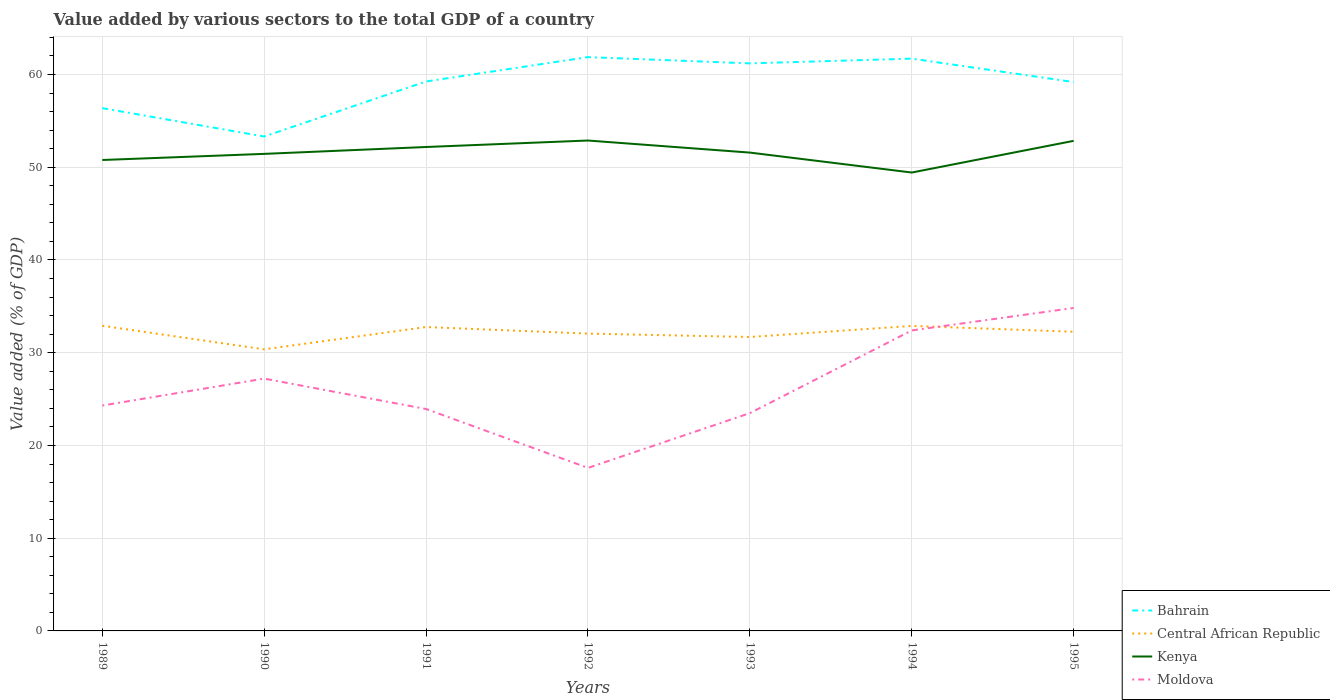Is the number of lines equal to the number of legend labels?
Ensure brevity in your answer.  Yes. Across all years, what is the maximum value added by various sectors to the total GDP in Kenya?
Provide a succinct answer. 49.43. In which year was the value added by various sectors to the total GDP in Moldova maximum?
Give a very brief answer. 1992. What is the total value added by various sectors to the total GDP in Bahrain in the graph?
Keep it short and to the point. -0.51. What is the difference between the highest and the second highest value added by various sectors to the total GDP in Central African Republic?
Make the answer very short. 2.54. How many lines are there?
Your answer should be compact. 4. What is the difference between two consecutive major ticks on the Y-axis?
Give a very brief answer. 10. Does the graph contain any zero values?
Offer a very short reply. No. Does the graph contain grids?
Your response must be concise. Yes. How many legend labels are there?
Make the answer very short. 4. How are the legend labels stacked?
Give a very brief answer. Vertical. What is the title of the graph?
Offer a terse response. Value added by various sectors to the total GDP of a country. Does "Korea (Republic)" appear as one of the legend labels in the graph?
Your answer should be compact. No. What is the label or title of the Y-axis?
Your answer should be compact. Value added (% of GDP). What is the Value added (% of GDP) of Bahrain in 1989?
Make the answer very short. 56.38. What is the Value added (% of GDP) of Central African Republic in 1989?
Provide a short and direct response. 32.91. What is the Value added (% of GDP) in Kenya in 1989?
Your answer should be compact. 50.78. What is the Value added (% of GDP) of Moldova in 1989?
Ensure brevity in your answer.  24.31. What is the Value added (% of GDP) of Bahrain in 1990?
Your answer should be compact. 53.32. What is the Value added (% of GDP) in Central African Republic in 1990?
Keep it short and to the point. 30.37. What is the Value added (% of GDP) of Kenya in 1990?
Ensure brevity in your answer.  51.44. What is the Value added (% of GDP) in Moldova in 1990?
Your answer should be compact. 27.21. What is the Value added (% of GDP) in Bahrain in 1991?
Your answer should be very brief. 59.25. What is the Value added (% of GDP) of Central African Republic in 1991?
Offer a very short reply. 32.77. What is the Value added (% of GDP) in Kenya in 1991?
Your answer should be compact. 52.18. What is the Value added (% of GDP) of Moldova in 1991?
Offer a very short reply. 23.93. What is the Value added (% of GDP) in Bahrain in 1992?
Your response must be concise. 61.88. What is the Value added (% of GDP) of Central African Republic in 1992?
Your answer should be compact. 32.06. What is the Value added (% of GDP) in Kenya in 1992?
Your answer should be very brief. 52.88. What is the Value added (% of GDP) of Moldova in 1992?
Your answer should be compact. 17.58. What is the Value added (% of GDP) in Bahrain in 1993?
Make the answer very short. 61.2. What is the Value added (% of GDP) of Central African Republic in 1993?
Your answer should be compact. 31.7. What is the Value added (% of GDP) of Kenya in 1993?
Your response must be concise. 51.58. What is the Value added (% of GDP) of Moldova in 1993?
Provide a short and direct response. 23.49. What is the Value added (% of GDP) in Bahrain in 1994?
Provide a succinct answer. 61.71. What is the Value added (% of GDP) of Central African Republic in 1994?
Provide a succinct answer. 32.89. What is the Value added (% of GDP) of Kenya in 1994?
Your answer should be compact. 49.43. What is the Value added (% of GDP) of Moldova in 1994?
Provide a succinct answer. 32.41. What is the Value added (% of GDP) of Bahrain in 1995?
Provide a succinct answer. 59.19. What is the Value added (% of GDP) of Central African Republic in 1995?
Keep it short and to the point. 32.26. What is the Value added (% of GDP) in Kenya in 1995?
Your response must be concise. 52.85. What is the Value added (% of GDP) in Moldova in 1995?
Ensure brevity in your answer.  34.83. Across all years, what is the maximum Value added (% of GDP) of Bahrain?
Keep it short and to the point. 61.88. Across all years, what is the maximum Value added (% of GDP) of Central African Republic?
Offer a terse response. 32.91. Across all years, what is the maximum Value added (% of GDP) of Kenya?
Offer a very short reply. 52.88. Across all years, what is the maximum Value added (% of GDP) in Moldova?
Offer a very short reply. 34.83. Across all years, what is the minimum Value added (% of GDP) in Bahrain?
Make the answer very short. 53.32. Across all years, what is the minimum Value added (% of GDP) in Central African Republic?
Make the answer very short. 30.37. Across all years, what is the minimum Value added (% of GDP) in Kenya?
Your answer should be very brief. 49.43. Across all years, what is the minimum Value added (% of GDP) of Moldova?
Offer a very short reply. 17.58. What is the total Value added (% of GDP) in Bahrain in the graph?
Your answer should be compact. 412.93. What is the total Value added (% of GDP) of Central African Republic in the graph?
Make the answer very short. 224.96. What is the total Value added (% of GDP) of Kenya in the graph?
Give a very brief answer. 361.16. What is the total Value added (% of GDP) of Moldova in the graph?
Provide a succinct answer. 183.74. What is the difference between the Value added (% of GDP) of Bahrain in 1989 and that in 1990?
Offer a very short reply. 3.06. What is the difference between the Value added (% of GDP) of Central African Republic in 1989 and that in 1990?
Provide a short and direct response. 2.54. What is the difference between the Value added (% of GDP) of Kenya in 1989 and that in 1990?
Your answer should be compact. -0.66. What is the difference between the Value added (% of GDP) of Moldova in 1989 and that in 1990?
Provide a succinct answer. -2.9. What is the difference between the Value added (% of GDP) of Bahrain in 1989 and that in 1991?
Make the answer very short. -2.88. What is the difference between the Value added (% of GDP) of Central African Republic in 1989 and that in 1991?
Your response must be concise. 0.14. What is the difference between the Value added (% of GDP) in Kenya in 1989 and that in 1991?
Ensure brevity in your answer.  -1.4. What is the difference between the Value added (% of GDP) of Moldova in 1989 and that in 1991?
Provide a succinct answer. 0.37. What is the difference between the Value added (% of GDP) in Bahrain in 1989 and that in 1992?
Keep it short and to the point. -5.5. What is the difference between the Value added (% of GDP) in Central African Republic in 1989 and that in 1992?
Provide a short and direct response. 0.85. What is the difference between the Value added (% of GDP) in Kenya in 1989 and that in 1992?
Give a very brief answer. -2.1. What is the difference between the Value added (% of GDP) of Moldova in 1989 and that in 1992?
Offer a terse response. 6.72. What is the difference between the Value added (% of GDP) in Bahrain in 1989 and that in 1993?
Provide a short and direct response. -4.83. What is the difference between the Value added (% of GDP) in Central African Republic in 1989 and that in 1993?
Your answer should be compact. 1.21. What is the difference between the Value added (% of GDP) of Kenya in 1989 and that in 1993?
Ensure brevity in your answer.  -0.8. What is the difference between the Value added (% of GDP) in Moldova in 1989 and that in 1993?
Make the answer very short. 0.82. What is the difference between the Value added (% of GDP) in Bahrain in 1989 and that in 1994?
Keep it short and to the point. -5.34. What is the difference between the Value added (% of GDP) of Central African Republic in 1989 and that in 1994?
Make the answer very short. 0.02. What is the difference between the Value added (% of GDP) of Kenya in 1989 and that in 1994?
Keep it short and to the point. 1.35. What is the difference between the Value added (% of GDP) of Moldova in 1989 and that in 1994?
Your answer should be very brief. -8.1. What is the difference between the Value added (% of GDP) in Bahrain in 1989 and that in 1995?
Offer a terse response. -2.81. What is the difference between the Value added (% of GDP) of Central African Republic in 1989 and that in 1995?
Ensure brevity in your answer.  0.65. What is the difference between the Value added (% of GDP) in Kenya in 1989 and that in 1995?
Your answer should be very brief. -2.07. What is the difference between the Value added (% of GDP) in Moldova in 1989 and that in 1995?
Ensure brevity in your answer.  -10.52. What is the difference between the Value added (% of GDP) in Bahrain in 1990 and that in 1991?
Your answer should be compact. -5.94. What is the difference between the Value added (% of GDP) in Central African Republic in 1990 and that in 1991?
Ensure brevity in your answer.  -2.41. What is the difference between the Value added (% of GDP) in Kenya in 1990 and that in 1991?
Your response must be concise. -0.74. What is the difference between the Value added (% of GDP) of Moldova in 1990 and that in 1991?
Keep it short and to the point. 3.28. What is the difference between the Value added (% of GDP) of Bahrain in 1990 and that in 1992?
Provide a succinct answer. -8.56. What is the difference between the Value added (% of GDP) in Central African Republic in 1990 and that in 1992?
Your answer should be compact. -1.7. What is the difference between the Value added (% of GDP) of Kenya in 1990 and that in 1992?
Your answer should be very brief. -1.44. What is the difference between the Value added (% of GDP) in Moldova in 1990 and that in 1992?
Your response must be concise. 9.63. What is the difference between the Value added (% of GDP) of Bahrain in 1990 and that in 1993?
Your answer should be very brief. -7.89. What is the difference between the Value added (% of GDP) of Central African Republic in 1990 and that in 1993?
Your answer should be very brief. -1.33. What is the difference between the Value added (% of GDP) of Kenya in 1990 and that in 1993?
Your response must be concise. -0.14. What is the difference between the Value added (% of GDP) of Moldova in 1990 and that in 1993?
Give a very brief answer. 3.72. What is the difference between the Value added (% of GDP) in Bahrain in 1990 and that in 1994?
Your answer should be very brief. -8.4. What is the difference between the Value added (% of GDP) in Central African Republic in 1990 and that in 1994?
Keep it short and to the point. -2.53. What is the difference between the Value added (% of GDP) in Kenya in 1990 and that in 1994?
Keep it short and to the point. 2.01. What is the difference between the Value added (% of GDP) of Moldova in 1990 and that in 1994?
Provide a succinct answer. -5.2. What is the difference between the Value added (% of GDP) in Bahrain in 1990 and that in 1995?
Make the answer very short. -5.87. What is the difference between the Value added (% of GDP) of Central African Republic in 1990 and that in 1995?
Keep it short and to the point. -1.9. What is the difference between the Value added (% of GDP) of Kenya in 1990 and that in 1995?
Ensure brevity in your answer.  -1.41. What is the difference between the Value added (% of GDP) in Moldova in 1990 and that in 1995?
Keep it short and to the point. -7.62. What is the difference between the Value added (% of GDP) of Bahrain in 1991 and that in 1992?
Your answer should be very brief. -2.63. What is the difference between the Value added (% of GDP) of Central African Republic in 1991 and that in 1992?
Provide a short and direct response. 0.71. What is the difference between the Value added (% of GDP) of Kenya in 1991 and that in 1992?
Ensure brevity in your answer.  -0.7. What is the difference between the Value added (% of GDP) of Moldova in 1991 and that in 1992?
Make the answer very short. 6.35. What is the difference between the Value added (% of GDP) of Bahrain in 1991 and that in 1993?
Make the answer very short. -1.95. What is the difference between the Value added (% of GDP) of Central African Republic in 1991 and that in 1993?
Make the answer very short. 1.08. What is the difference between the Value added (% of GDP) in Kenya in 1991 and that in 1993?
Give a very brief answer. 0.6. What is the difference between the Value added (% of GDP) of Moldova in 1991 and that in 1993?
Give a very brief answer. 0.45. What is the difference between the Value added (% of GDP) in Bahrain in 1991 and that in 1994?
Offer a very short reply. -2.46. What is the difference between the Value added (% of GDP) in Central African Republic in 1991 and that in 1994?
Your answer should be compact. -0.12. What is the difference between the Value added (% of GDP) in Kenya in 1991 and that in 1994?
Your answer should be compact. 2.75. What is the difference between the Value added (% of GDP) in Moldova in 1991 and that in 1994?
Your response must be concise. -8.47. What is the difference between the Value added (% of GDP) in Bahrain in 1991 and that in 1995?
Your answer should be compact. 0.06. What is the difference between the Value added (% of GDP) of Central African Republic in 1991 and that in 1995?
Offer a very short reply. 0.51. What is the difference between the Value added (% of GDP) in Kenya in 1991 and that in 1995?
Your answer should be very brief. -0.66. What is the difference between the Value added (% of GDP) of Moldova in 1991 and that in 1995?
Offer a very short reply. -10.9. What is the difference between the Value added (% of GDP) of Bahrain in 1992 and that in 1993?
Your answer should be very brief. 0.68. What is the difference between the Value added (% of GDP) in Central African Republic in 1992 and that in 1993?
Your response must be concise. 0.37. What is the difference between the Value added (% of GDP) in Kenya in 1992 and that in 1993?
Your response must be concise. 1.3. What is the difference between the Value added (% of GDP) of Moldova in 1992 and that in 1993?
Your response must be concise. -5.9. What is the difference between the Value added (% of GDP) in Bahrain in 1992 and that in 1994?
Give a very brief answer. 0.16. What is the difference between the Value added (% of GDP) in Central African Republic in 1992 and that in 1994?
Ensure brevity in your answer.  -0.83. What is the difference between the Value added (% of GDP) of Kenya in 1992 and that in 1994?
Provide a succinct answer. 3.45. What is the difference between the Value added (% of GDP) in Moldova in 1992 and that in 1994?
Give a very brief answer. -14.82. What is the difference between the Value added (% of GDP) of Bahrain in 1992 and that in 1995?
Make the answer very short. 2.69. What is the difference between the Value added (% of GDP) in Central African Republic in 1992 and that in 1995?
Offer a terse response. -0.2. What is the difference between the Value added (% of GDP) in Kenya in 1992 and that in 1995?
Offer a very short reply. 0.03. What is the difference between the Value added (% of GDP) in Moldova in 1992 and that in 1995?
Your answer should be compact. -17.25. What is the difference between the Value added (% of GDP) of Bahrain in 1993 and that in 1994?
Keep it short and to the point. -0.51. What is the difference between the Value added (% of GDP) in Central African Republic in 1993 and that in 1994?
Offer a very short reply. -1.2. What is the difference between the Value added (% of GDP) in Kenya in 1993 and that in 1994?
Provide a short and direct response. 2.15. What is the difference between the Value added (% of GDP) of Moldova in 1993 and that in 1994?
Provide a short and direct response. -8.92. What is the difference between the Value added (% of GDP) in Bahrain in 1993 and that in 1995?
Offer a very short reply. 2.01. What is the difference between the Value added (% of GDP) of Central African Republic in 1993 and that in 1995?
Provide a succinct answer. -0.57. What is the difference between the Value added (% of GDP) in Kenya in 1993 and that in 1995?
Make the answer very short. -1.27. What is the difference between the Value added (% of GDP) in Moldova in 1993 and that in 1995?
Provide a short and direct response. -11.34. What is the difference between the Value added (% of GDP) of Bahrain in 1994 and that in 1995?
Keep it short and to the point. 2.53. What is the difference between the Value added (% of GDP) in Central African Republic in 1994 and that in 1995?
Your answer should be very brief. 0.63. What is the difference between the Value added (% of GDP) of Kenya in 1994 and that in 1995?
Offer a very short reply. -3.42. What is the difference between the Value added (% of GDP) of Moldova in 1994 and that in 1995?
Your answer should be very brief. -2.42. What is the difference between the Value added (% of GDP) in Bahrain in 1989 and the Value added (% of GDP) in Central African Republic in 1990?
Make the answer very short. 26.01. What is the difference between the Value added (% of GDP) of Bahrain in 1989 and the Value added (% of GDP) of Kenya in 1990?
Provide a succinct answer. 4.93. What is the difference between the Value added (% of GDP) in Bahrain in 1989 and the Value added (% of GDP) in Moldova in 1990?
Provide a short and direct response. 29.17. What is the difference between the Value added (% of GDP) of Central African Republic in 1989 and the Value added (% of GDP) of Kenya in 1990?
Your answer should be compact. -18.54. What is the difference between the Value added (% of GDP) of Central African Republic in 1989 and the Value added (% of GDP) of Moldova in 1990?
Keep it short and to the point. 5.7. What is the difference between the Value added (% of GDP) of Kenya in 1989 and the Value added (% of GDP) of Moldova in 1990?
Your answer should be compact. 23.57. What is the difference between the Value added (% of GDP) of Bahrain in 1989 and the Value added (% of GDP) of Central African Republic in 1991?
Your answer should be compact. 23.6. What is the difference between the Value added (% of GDP) of Bahrain in 1989 and the Value added (% of GDP) of Kenya in 1991?
Keep it short and to the point. 4.19. What is the difference between the Value added (% of GDP) of Bahrain in 1989 and the Value added (% of GDP) of Moldova in 1991?
Your answer should be compact. 32.44. What is the difference between the Value added (% of GDP) of Central African Republic in 1989 and the Value added (% of GDP) of Kenya in 1991?
Make the answer very short. -19.28. What is the difference between the Value added (% of GDP) in Central African Republic in 1989 and the Value added (% of GDP) in Moldova in 1991?
Keep it short and to the point. 8.98. What is the difference between the Value added (% of GDP) of Kenya in 1989 and the Value added (% of GDP) of Moldova in 1991?
Give a very brief answer. 26.85. What is the difference between the Value added (% of GDP) in Bahrain in 1989 and the Value added (% of GDP) in Central African Republic in 1992?
Keep it short and to the point. 24.31. What is the difference between the Value added (% of GDP) in Bahrain in 1989 and the Value added (% of GDP) in Kenya in 1992?
Your answer should be very brief. 3.49. What is the difference between the Value added (% of GDP) in Bahrain in 1989 and the Value added (% of GDP) in Moldova in 1992?
Provide a succinct answer. 38.8. What is the difference between the Value added (% of GDP) in Central African Republic in 1989 and the Value added (% of GDP) in Kenya in 1992?
Give a very brief answer. -19.98. What is the difference between the Value added (% of GDP) of Central African Republic in 1989 and the Value added (% of GDP) of Moldova in 1992?
Provide a short and direct response. 15.33. What is the difference between the Value added (% of GDP) in Kenya in 1989 and the Value added (% of GDP) in Moldova in 1992?
Provide a succinct answer. 33.2. What is the difference between the Value added (% of GDP) of Bahrain in 1989 and the Value added (% of GDP) of Central African Republic in 1993?
Your answer should be very brief. 24.68. What is the difference between the Value added (% of GDP) of Bahrain in 1989 and the Value added (% of GDP) of Kenya in 1993?
Provide a short and direct response. 4.79. What is the difference between the Value added (% of GDP) in Bahrain in 1989 and the Value added (% of GDP) in Moldova in 1993?
Ensure brevity in your answer.  32.89. What is the difference between the Value added (% of GDP) in Central African Republic in 1989 and the Value added (% of GDP) in Kenya in 1993?
Provide a succinct answer. -18.67. What is the difference between the Value added (% of GDP) of Central African Republic in 1989 and the Value added (% of GDP) of Moldova in 1993?
Give a very brief answer. 9.42. What is the difference between the Value added (% of GDP) of Kenya in 1989 and the Value added (% of GDP) of Moldova in 1993?
Provide a short and direct response. 27.3. What is the difference between the Value added (% of GDP) of Bahrain in 1989 and the Value added (% of GDP) of Central African Republic in 1994?
Give a very brief answer. 23.48. What is the difference between the Value added (% of GDP) of Bahrain in 1989 and the Value added (% of GDP) of Kenya in 1994?
Ensure brevity in your answer.  6.94. What is the difference between the Value added (% of GDP) of Bahrain in 1989 and the Value added (% of GDP) of Moldova in 1994?
Provide a succinct answer. 23.97. What is the difference between the Value added (% of GDP) in Central African Republic in 1989 and the Value added (% of GDP) in Kenya in 1994?
Ensure brevity in your answer.  -16.52. What is the difference between the Value added (% of GDP) of Central African Republic in 1989 and the Value added (% of GDP) of Moldova in 1994?
Keep it short and to the point. 0.5. What is the difference between the Value added (% of GDP) in Kenya in 1989 and the Value added (% of GDP) in Moldova in 1994?
Give a very brief answer. 18.38. What is the difference between the Value added (% of GDP) in Bahrain in 1989 and the Value added (% of GDP) in Central African Republic in 1995?
Offer a terse response. 24.11. What is the difference between the Value added (% of GDP) of Bahrain in 1989 and the Value added (% of GDP) of Kenya in 1995?
Your answer should be very brief. 3.53. What is the difference between the Value added (% of GDP) in Bahrain in 1989 and the Value added (% of GDP) in Moldova in 1995?
Offer a very short reply. 21.55. What is the difference between the Value added (% of GDP) of Central African Republic in 1989 and the Value added (% of GDP) of Kenya in 1995?
Your response must be concise. -19.94. What is the difference between the Value added (% of GDP) in Central African Republic in 1989 and the Value added (% of GDP) in Moldova in 1995?
Provide a short and direct response. -1.92. What is the difference between the Value added (% of GDP) in Kenya in 1989 and the Value added (% of GDP) in Moldova in 1995?
Ensure brevity in your answer.  15.96. What is the difference between the Value added (% of GDP) in Bahrain in 1990 and the Value added (% of GDP) in Central African Republic in 1991?
Your answer should be compact. 20.54. What is the difference between the Value added (% of GDP) of Bahrain in 1990 and the Value added (% of GDP) of Kenya in 1991?
Make the answer very short. 1.13. What is the difference between the Value added (% of GDP) of Bahrain in 1990 and the Value added (% of GDP) of Moldova in 1991?
Offer a terse response. 29.38. What is the difference between the Value added (% of GDP) in Central African Republic in 1990 and the Value added (% of GDP) in Kenya in 1991?
Your response must be concise. -21.82. What is the difference between the Value added (% of GDP) of Central African Republic in 1990 and the Value added (% of GDP) of Moldova in 1991?
Make the answer very short. 6.43. What is the difference between the Value added (% of GDP) in Kenya in 1990 and the Value added (% of GDP) in Moldova in 1991?
Your response must be concise. 27.51. What is the difference between the Value added (% of GDP) in Bahrain in 1990 and the Value added (% of GDP) in Central African Republic in 1992?
Ensure brevity in your answer.  21.25. What is the difference between the Value added (% of GDP) of Bahrain in 1990 and the Value added (% of GDP) of Kenya in 1992?
Offer a very short reply. 0.43. What is the difference between the Value added (% of GDP) in Bahrain in 1990 and the Value added (% of GDP) in Moldova in 1992?
Provide a succinct answer. 35.74. What is the difference between the Value added (% of GDP) in Central African Republic in 1990 and the Value added (% of GDP) in Kenya in 1992?
Give a very brief answer. -22.52. What is the difference between the Value added (% of GDP) of Central African Republic in 1990 and the Value added (% of GDP) of Moldova in 1992?
Your answer should be very brief. 12.79. What is the difference between the Value added (% of GDP) of Kenya in 1990 and the Value added (% of GDP) of Moldova in 1992?
Make the answer very short. 33.86. What is the difference between the Value added (% of GDP) in Bahrain in 1990 and the Value added (% of GDP) in Central African Republic in 1993?
Offer a terse response. 21.62. What is the difference between the Value added (% of GDP) in Bahrain in 1990 and the Value added (% of GDP) in Kenya in 1993?
Make the answer very short. 1.73. What is the difference between the Value added (% of GDP) in Bahrain in 1990 and the Value added (% of GDP) in Moldova in 1993?
Ensure brevity in your answer.  29.83. What is the difference between the Value added (% of GDP) in Central African Republic in 1990 and the Value added (% of GDP) in Kenya in 1993?
Provide a short and direct response. -21.22. What is the difference between the Value added (% of GDP) of Central African Republic in 1990 and the Value added (% of GDP) of Moldova in 1993?
Offer a terse response. 6.88. What is the difference between the Value added (% of GDP) in Kenya in 1990 and the Value added (% of GDP) in Moldova in 1993?
Offer a very short reply. 27.96. What is the difference between the Value added (% of GDP) of Bahrain in 1990 and the Value added (% of GDP) of Central African Republic in 1994?
Your answer should be compact. 20.42. What is the difference between the Value added (% of GDP) in Bahrain in 1990 and the Value added (% of GDP) in Kenya in 1994?
Your answer should be very brief. 3.88. What is the difference between the Value added (% of GDP) of Bahrain in 1990 and the Value added (% of GDP) of Moldova in 1994?
Your response must be concise. 20.91. What is the difference between the Value added (% of GDP) in Central African Republic in 1990 and the Value added (% of GDP) in Kenya in 1994?
Keep it short and to the point. -19.07. What is the difference between the Value added (% of GDP) of Central African Republic in 1990 and the Value added (% of GDP) of Moldova in 1994?
Keep it short and to the point. -2.04. What is the difference between the Value added (% of GDP) in Kenya in 1990 and the Value added (% of GDP) in Moldova in 1994?
Your response must be concise. 19.04. What is the difference between the Value added (% of GDP) in Bahrain in 1990 and the Value added (% of GDP) in Central African Republic in 1995?
Offer a terse response. 21.05. What is the difference between the Value added (% of GDP) in Bahrain in 1990 and the Value added (% of GDP) in Kenya in 1995?
Offer a very short reply. 0.47. What is the difference between the Value added (% of GDP) of Bahrain in 1990 and the Value added (% of GDP) of Moldova in 1995?
Make the answer very short. 18.49. What is the difference between the Value added (% of GDP) of Central African Republic in 1990 and the Value added (% of GDP) of Kenya in 1995?
Provide a succinct answer. -22.48. What is the difference between the Value added (% of GDP) in Central African Republic in 1990 and the Value added (% of GDP) in Moldova in 1995?
Give a very brief answer. -4.46. What is the difference between the Value added (% of GDP) of Kenya in 1990 and the Value added (% of GDP) of Moldova in 1995?
Ensure brevity in your answer.  16.62. What is the difference between the Value added (% of GDP) in Bahrain in 1991 and the Value added (% of GDP) in Central African Republic in 1992?
Provide a short and direct response. 27.19. What is the difference between the Value added (% of GDP) of Bahrain in 1991 and the Value added (% of GDP) of Kenya in 1992?
Ensure brevity in your answer.  6.37. What is the difference between the Value added (% of GDP) of Bahrain in 1991 and the Value added (% of GDP) of Moldova in 1992?
Provide a short and direct response. 41.67. What is the difference between the Value added (% of GDP) in Central African Republic in 1991 and the Value added (% of GDP) in Kenya in 1992?
Provide a succinct answer. -20.11. What is the difference between the Value added (% of GDP) of Central African Republic in 1991 and the Value added (% of GDP) of Moldova in 1992?
Give a very brief answer. 15.19. What is the difference between the Value added (% of GDP) of Kenya in 1991 and the Value added (% of GDP) of Moldova in 1992?
Provide a short and direct response. 34.6. What is the difference between the Value added (% of GDP) of Bahrain in 1991 and the Value added (% of GDP) of Central African Republic in 1993?
Give a very brief answer. 27.56. What is the difference between the Value added (% of GDP) in Bahrain in 1991 and the Value added (% of GDP) in Kenya in 1993?
Offer a terse response. 7.67. What is the difference between the Value added (% of GDP) in Bahrain in 1991 and the Value added (% of GDP) in Moldova in 1993?
Provide a short and direct response. 35.77. What is the difference between the Value added (% of GDP) in Central African Republic in 1991 and the Value added (% of GDP) in Kenya in 1993?
Your answer should be very brief. -18.81. What is the difference between the Value added (% of GDP) in Central African Republic in 1991 and the Value added (% of GDP) in Moldova in 1993?
Your answer should be very brief. 9.29. What is the difference between the Value added (% of GDP) in Kenya in 1991 and the Value added (% of GDP) in Moldova in 1993?
Keep it short and to the point. 28.7. What is the difference between the Value added (% of GDP) of Bahrain in 1991 and the Value added (% of GDP) of Central African Republic in 1994?
Provide a succinct answer. 26.36. What is the difference between the Value added (% of GDP) of Bahrain in 1991 and the Value added (% of GDP) of Kenya in 1994?
Your answer should be very brief. 9.82. What is the difference between the Value added (% of GDP) in Bahrain in 1991 and the Value added (% of GDP) in Moldova in 1994?
Offer a terse response. 26.85. What is the difference between the Value added (% of GDP) of Central African Republic in 1991 and the Value added (% of GDP) of Kenya in 1994?
Ensure brevity in your answer.  -16.66. What is the difference between the Value added (% of GDP) of Central African Republic in 1991 and the Value added (% of GDP) of Moldova in 1994?
Your response must be concise. 0.37. What is the difference between the Value added (% of GDP) in Kenya in 1991 and the Value added (% of GDP) in Moldova in 1994?
Ensure brevity in your answer.  19.78. What is the difference between the Value added (% of GDP) of Bahrain in 1991 and the Value added (% of GDP) of Central African Republic in 1995?
Ensure brevity in your answer.  26.99. What is the difference between the Value added (% of GDP) of Bahrain in 1991 and the Value added (% of GDP) of Kenya in 1995?
Your answer should be very brief. 6.4. What is the difference between the Value added (% of GDP) of Bahrain in 1991 and the Value added (% of GDP) of Moldova in 1995?
Give a very brief answer. 24.43. What is the difference between the Value added (% of GDP) of Central African Republic in 1991 and the Value added (% of GDP) of Kenya in 1995?
Offer a very short reply. -20.08. What is the difference between the Value added (% of GDP) in Central African Republic in 1991 and the Value added (% of GDP) in Moldova in 1995?
Give a very brief answer. -2.06. What is the difference between the Value added (% of GDP) in Kenya in 1991 and the Value added (% of GDP) in Moldova in 1995?
Give a very brief answer. 17.36. What is the difference between the Value added (% of GDP) of Bahrain in 1992 and the Value added (% of GDP) of Central African Republic in 1993?
Provide a short and direct response. 30.18. What is the difference between the Value added (% of GDP) of Bahrain in 1992 and the Value added (% of GDP) of Kenya in 1993?
Ensure brevity in your answer.  10.3. What is the difference between the Value added (% of GDP) of Bahrain in 1992 and the Value added (% of GDP) of Moldova in 1993?
Ensure brevity in your answer.  38.39. What is the difference between the Value added (% of GDP) in Central African Republic in 1992 and the Value added (% of GDP) in Kenya in 1993?
Provide a short and direct response. -19.52. What is the difference between the Value added (% of GDP) of Central African Republic in 1992 and the Value added (% of GDP) of Moldova in 1993?
Your answer should be compact. 8.58. What is the difference between the Value added (% of GDP) of Kenya in 1992 and the Value added (% of GDP) of Moldova in 1993?
Provide a short and direct response. 29.4. What is the difference between the Value added (% of GDP) of Bahrain in 1992 and the Value added (% of GDP) of Central African Republic in 1994?
Your response must be concise. 28.99. What is the difference between the Value added (% of GDP) of Bahrain in 1992 and the Value added (% of GDP) of Kenya in 1994?
Give a very brief answer. 12.45. What is the difference between the Value added (% of GDP) of Bahrain in 1992 and the Value added (% of GDP) of Moldova in 1994?
Keep it short and to the point. 29.47. What is the difference between the Value added (% of GDP) of Central African Republic in 1992 and the Value added (% of GDP) of Kenya in 1994?
Your answer should be very brief. -17.37. What is the difference between the Value added (% of GDP) in Central African Republic in 1992 and the Value added (% of GDP) in Moldova in 1994?
Offer a terse response. -0.34. What is the difference between the Value added (% of GDP) in Kenya in 1992 and the Value added (% of GDP) in Moldova in 1994?
Offer a very short reply. 20.48. What is the difference between the Value added (% of GDP) in Bahrain in 1992 and the Value added (% of GDP) in Central African Republic in 1995?
Ensure brevity in your answer.  29.62. What is the difference between the Value added (% of GDP) in Bahrain in 1992 and the Value added (% of GDP) in Kenya in 1995?
Give a very brief answer. 9.03. What is the difference between the Value added (% of GDP) of Bahrain in 1992 and the Value added (% of GDP) of Moldova in 1995?
Offer a terse response. 27.05. What is the difference between the Value added (% of GDP) of Central African Republic in 1992 and the Value added (% of GDP) of Kenya in 1995?
Give a very brief answer. -20.79. What is the difference between the Value added (% of GDP) of Central African Republic in 1992 and the Value added (% of GDP) of Moldova in 1995?
Offer a terse response. -2.76. What is the difference between the Value added (% of GDP) in Kenya in 1992 and the Value added (% of GDP) in Moldova in 1995?
Keep it short and to the point. 18.06. What is the difference between the Value added (% of GDP) in Bahrain in 1993 and the Value added (% of GDP) in Central African Republic in 1994?
Provide a succinct answer. 28.31. What is the difference between the Value added (% of GDP) in Bahrain in 1993 and the Value added (% of GDP) in Kenya in 1994?
Provide a short and direct response. 11.77. What is the difference between the Value added (% of GDP) of Bahrain in 1993 and the Value added (% of GDP) of Moldova in 1994?
Offer a terse response. 28.8. What is the difference between the Value added (% of GDP) of Central African Republic in 1993 and the Value added (% of GDP) of Kenya in 1994?
Give a very brief answer. -17.74. What is the difference between the Value added (% of GDP) of Central African Republic in 1993 and the Value added (% of GDP) of Moldova in 1994?
Your answer should be compact. -0.71. What is the difference between the Value added (% of GDP) of Kenya in 1993 and the Value added (% of GDP) of Moldova in 1994?
Your answer should be very brief. 19.18. What is the difference between the Value added (% of GDP) in Bahrain in 1993 and the Value added (% of GDP) in Central African Republic in 1995?
Keep it short and to the point. 28.94. What is the difference between the Value added (% of GDP) of Bahrain in 1993 and the Value added (% of GDP) of Kenya in 1995?
Keep it short and to the point. 8.35. What is the difference between the Value added (% of GDP) in Bahrain in 1993 and the Value added (% of GDP) in Moldova in 1995?
Your answer should be very brief. 26.38. What is the difference between the Value added (% of GDP) in Central African Republic in 1993 and the Value added (% of GDP) in Kenya in 1995?
Provide a short and direct response. -21.15. What is the difference between the Value added (% of GDP) of Central African Republic in 1993 and the Value added (% of GDP) of Moldova in 1995?
Your answer should be very brief. -3.13. What is the difference between the Value added (% of GDP) in Kenya in 1993 and the Value added (% of GDP) in Moldova in 1995?
Your answer should be compact. 16.76. What is the difference between the Value added (% of GDP) of Bahrain in 1994 and the Value added (% of GDP) of Central African Republic in 1995?
Your answer should be compact. 29.45. What is the difference between the Value added (% of GDP) of Bahrain in 1994 and the Value added (% of GDP) of Kenya in 1995?
Give a very brief answer. 8.87. What is the difference between the Value added (% of GDP) of Bahrain in 1994 and the Value added (% of GDP) of Moldova in 1995?
Provide a short and direct response. 26.89. What is the difference between the Value added (% of GDP) in Central African Republic in 1994 and the Value added (% of GDP) in Kenya in 1995?
Ensure brevity in your answer.  -19.96. What is the difference between the Value added (% of GDP) in Central African Republic in 1994 and the Value added (% of GDP) in Moldova in 1995?
Ensure brevity in your answer.  -1.93. What is the difference between the Value added (% of GDP) in Kenya in 1994 and the Value added (% of GDP) in Moldova in 1995?
Offer a very short reply. 14.61. What is the average Value added (% of GDP) in Bahrain per year?
Your answer should be compact. 58.99. What is the average Value added (% of GDP) of Central African Republic per year?
Provide a succinct answer. 32.14. What is the average Value added (% of GDP) of Kenya per year?
Your answer should be very brief. 51.59. What is the average Value added (% of GDP) in Moldova per year?
Offer a terse response. 26.25. In the year 1989, what is the difference between the Value added (% of GDP) in Bahrain and Value added (% of GDP) in Central African Republic?
Keep it short and to the point. 23.47. In the year 1989, what is the difference between the Value added (% of GDP) of Bahrain and Value added (% of GDP) of Kenya?
Make the answer very short. 5.59. In the year 1989, what is the difference between the Value added (% of GDP) of Bahrain and Value added (% of GDP) of Moldova?
Offer a very short reply. 32.07. In the year 1989, what is the difference between the Value added (% of GDP) in Central African Republic and Value added (% of GDP) in Kenya?
Ensure brevity in your answer.  -17.87. In the year 1989, what is the difference between the Value added (% of GDP) of Central African Republic and Value added (% of GDP) of Moldova?
Keep it short and to the point. 8.6. In the year 1989, what is the difference between the Value added (% of GDP) of Kenya and Value added (% of GDP) of Moldova?
Your response must be concise. 26.48. In the year 1990, what is the difference between the Value added (% of GDP) in Bahrain and Value added (% of GDP) in Central African Republic?
Ensure brevity in your answer.  22.95. In the year 1990, what is the difference between the Value added (% of GDP) in Bahrain and Value added (% of GDP) in Kenya?
Make the answer very short. 1.87. In the year 1990, what is the difference between the Value added (% of GDP) in Bahrain and Value added (% of GDP) in Moldova?
Offer a very short reply. 26.11. In the year 1990, what is the difference between the Value added (% of GDP) in Central African Republic and Value added (% of GDP) in Kenya?
Ensure brevity in your answer.  -21.08. In the year 1990, what is the difference between the Value added (% of GDP) in Central African Republic and Value added (% of GDP) in Moldova?
Keep it short and to the point. 3.16. In the year 1990, what is the difference between the Value added (% of GDP) in Kenya and Value added (% of GDP) in Moldova?
Ensure brevity in your answer.  24.23. In the year 1991, what is the difference between the Value added (% of GDP) in Bahrain and Value added (% of GDP) in Central African Republic?
Give a very brief answer. 26.48. In the year 1991, what is the difference between the Value added (% of GDP) in Bahrain and Value added (% of GDP) in Kenya?
Provide a succinct answer. 7.07. In the year 1991, what is the difference between the Value added (% of GDP) in Bahrain and Value added (% of GDP) in Moldova?
Ensure brevity in your answer.  35.32. In the year 1991, what is the difference between the Value added (% of GDP) in Central African Republic and Value added (% of GDP) in Kenya?
Your answer should be very brief. -19.41. In the year 1991, what is the difference between the Value added (% of GDP) in Central African Republic and Value added (% of GDP) in Moldova?
Offer a terse response. 8.84. In the year 1991, what is the difference between the Value added (% of GDP) of Kenya and Value added (% of GDP) of Moldova?
Offer a terse response. 28.25. In the year 1992, what is the difference between the Value added (% of GDP) of Bahrain and Value added (% of GDP) of Central African Republic?
Your response must be concise. 29.82. In the year 1992, what is the difference between the Value added (% of GDP) of Bahrain and Value added (% of GDP) of Kenya?
Your answer should be very brief. 8.99. In the year 1992, what is the difference between the Value added (% of GDP) of Bahrain and Value added (% of GDP) of Moldova?
Provide a short and direct response. 44.3. In the year 1992, what is the difference between the Value added (% of GDP) in Central African Republic and Value added (% of GDP) in Kenya?
Keep it short and to the point. -20.82. In the year 1992, what is the difference between the Value added (% of GDP) of Central African Republic and Value added (% of GDP) of Moldova?
Your answer should be compact. 14.48. In the year 1992, what is the difference between the Value added (% of GDP) in Kenya and Value added (% of GDP) in Moldova?
Your response must be concise. 35.3. In the year 1993, what is the difference between the Value added (% of GDP) in Bahrain and Value added (% of GDP) in Central African Republic?
Your answer should be compact. 29.51. In the year 1993, what is the difference between the Value added (% of GDP) in Bahrain and Value added (% of GDP) in Kenya?
Keep it short and to the point. 9.62. In the year 1993, what is the difference between the Value added (% of GDP) in Bahrain and Value added (% of GDP) in Moldova?
Your response must be concise. 37.72. In the year 1993, what is the difference between the Value added (% of GDP) of Central African Republic and Value added (% of GDP) of Kenya?
Keep it short and to the point. -19.89. In the year 1993, what is the difference between the Value added (% of GDP) of Central African Republic and Value added (% of GDP) of Moldova?
Your answer should be compact. 8.21. In the year 1993, what is the difference between the Value added (% of GDP) of Kenya and Value added (% of GDP) of Moldova?
Offer a very short reply. 28.1. In the year 1994, what is the difference between the Value added (% of GDP) in Bahrain and Value added (% of GDP) in Central African Republic?
Your answer should be very brief. 28.82. In the year 1994, what is the difference between the Value added (% of GDP) of Bahrain and Value added (% of GDP) of Kenya?
Give a very brief answer. 12.28. In the year 1994, what is the difference between the Value added (% of GDP) of Bahrain and Value added (% of GDP) of Moldova?
Ensure brevity in your answer.  29.31. In the year 1994, what is the difference between the Value added (% of GDP) of Central African Republic and Value added (% of GDP) of Kenya?
Keep it short and to the point. -16.54. In the year 1994, what is the difference between the Value added (% of GDP) in Central African Republic and Value added (% of GDP) in Moldova?
Ensure brevity in your answer.  0.49. In the year 1994, what is the difference between the Value added (% of GDP) of Kenya and Value added (% of GDP) of Moldova?
Your answer should be compact. 17.03. In the year 1995, what is the difference between the Value added (% of GDP) in Bahrain and Value added (% of GDP) in Central African Republic?
Your answer should be compact. 26.93. In the year 1995, what is the difference between the Value added (% of GDP) of Bahrain and Value added (% of GDP) of Kenya?
Make the answer very short. 6.34. In the year 1995, what is the difference between the Value added (% of GDP) of Bahrain and Value added (% of GDP) of Moldova?
Your response must be concise. 24.36. In the year 1995, what is the difference between the Value added (% of GDP) of Central African Republic and Value added (% of GDP) of Kenya?
Your answer should be very brief. -20.59. In the year 1995, what is the difference between the Value added (% of GDP) of Central African Republic and Value added (% of GDP) of Moldova?
Your answer should be compact. -2.56. In the year 1995, what is the difference between the Value added (% of GDP) in Kenya and Value added (% of GDP) in Moldova?
Your answer should be compact. 18.02. What is the ratio of the Value added (% of GDP) of Bahrain in 1989 to that in 1990?
Your answer should be very brief. 1.06. What is the ratio of the Value added (% of GDP) of Central African Republic in 1989 to that in 1990?
Offer a very short reply. 1.08. What is the ratio of the Value added (% of GDP) in Kenya in 1989 to that in 1990?
Ensure brevity in your answer.  0.99. What is the ratio of the Value added (% of GDP) in Moldova in 1989 to that in 1990?
Keep it short and to the point. 0.89. What is the ratio of the Value added (% of GDP) of Bahrain in 1989 to that in 1991?
Provide a short and direct response. 0.95. What is the ratio of the Value added (% of GDP) of Central African Republic in 1989 to that in 1991?
Your response must be concise. 1. What is the ratio of the Value added (% of GDP) in Kenya in 1989 to that in 1991?
Offer a very short reply. 0.97. What is the ratio of the Value added (% of GDP) in Moldova in 1989 to that in 1991?
Offer a very short reply. 1.02. What is the ratio of the Value added (% of GDP) in Bahrain in 1989 to that in 1992?
Make the answer very short. 0.91. What is the ratio of the Value added (% of GDP) of Central African Republic in 1989 to that in 1992?
Keep it short and to the point. 1.03. What is the ratio of the Value added (% of GDP) in Kenya in 1989 to that in 1992?
Your response must be concise. 0.96. What is the ratio of the Value added (% of GDP) in Moldova in 1989 to that in 1992?
Offer a very short reply. 1.38. What is the ratio of the Value added (% of GDP) of Bahrain in 1989 to that in 1993?
Offer a very short reply. 0.92. What is the ratio of the Value added (% of GDP) in Central African Republic in 1989 to that in 1993?
Offer a very short reply. 1.04. What is the ratio of the Value added (% of GDP) of Kenya in 1989 to that in 1993?
Your answer should be compact. 0.98. What is the ratio of the Value added (% of GDP) in Moldova in 1989 to that in 1993?
Keep it short and to the point. 1.03. What is the ratio of the Value added (% of GDP) of Bahrain in 1989 to that in 1994?
Your answer should be very brief. 0.91. What is the ratio of the Value added (% of GDP) in Kenya in 1989 to that in 1994?
Your response must be concise. 1.03. What is the ratio of the Value added (% of GDP) of Moldova in 1989 to that in 1994?
Offer a very short reply. 0.75. What is the ratio of the Value added (% of GDP) of Bahrain in 1989 to that in 1995?
Your answer should be very brief. 0.95. What is the ratio of the Value added (% of GDP) of Kenya in 1989 to that in 1995?
Ensure brevity in your answer.  0.96. What is the ratio of the Value added (% of GDP) of Moldova in 1989 to that in 1995?
Provide a short and direct response. 0.7. What is the ratio of the Value added (% of GDP) in Bahrain in 1990 to that in 1991?
Keep it short and to the point. 0.9. What is the ratio of the Value added (% of GDP) in Central African Republic in 1990 to that in 1991?
Your answer should be very brief. 0.93. What is the ratio of the Value added (% of GDP) in Kenya in 1990 to that in 1991?
Provide a short and direct response. 0.99. What is the ratio of the Value added (% of GDP) of Moldova in 1990 to that in 1991?
Your response must be concise. 1.14. What is the ratio of the Value added (% of GDP) of Bahrain in 1990 to that in 1992?
Offer a terse response. 0.86. What is the ratio of the Value added (% of GDP) in Central African Republic in 1990 to that in 1992?
Give a very brief answer. 0.95. What is the ratio of the Value added (% of GDP) of Kenya in 1990 to that in 1992?
Provide a short and direct response. 0.97. What is the ratio of the Value added (% of GDP) in Moldova in 1990 to that in 1992?
Your answer should be compact. 1.55. What is the ratio of the Value added (% of GDP) in Bahrain in 1990 to that in 1993?
Provide a succinct answer. 0.87. What is the ratio of the Value added (% of GDP) in Central African Republic in 1990 to that in 1993?
Your response must be concise. 0.96. What is the ratio of the Value added (% of GDP) in Kenya in 1990 to that in 1993?
Offer a terse response. 1. What is the ratio of the Value added (% of GDP) of Moldova in 1990 to that in 1993?
Provide a succinct answer. 1.16. What is the ratio of the Value added (% of GDP) of Bahrain in 1990 to that in 1994?
Offer a terse response. 0.86. What is the ratio of the Value added (% of GDP) in Central African Republic in 1990 to that in 1994?
Your answer should be very brief. 0.92. What is the ratio of the Value added (% of GDP) of Kenya in 1990 to that in 1994?
Offer a terse response. 1.04. What is the ratio of the Value added (% of GDP) of Moldova in 1990 to that in 1994?
Your answer should be very brief. 0.84. What is the ratio of the Value added (% of GDP) in Bahrain in 1990 to that in 1995?
Offer a terse response. 0.9. What is the ratio of the Value added (% of GDP) in Central African Republic in 1990 to that in 1995?
Make the answer very short. 0.94. What is the ratio of the Value added (% of GDP) of Kenya in 1990 to that in 1995?
Offer a very short reply. 0.97. What is the ratio of the Value added (% of GDP) in Moldova in 1990 to that in 1995?
Provide a succinct answer. 0.78. What is the ratio of the Value added (% of GDP) in Bahrain in 1991 to that in 1992?
Your response must be concise. 0.96. What is the ratio of the Value added (% of GDP) in Central African Republic in 1991 to that in 1992?
Your answer should be very brief. 1.02. What is the ratio of the Value added (% of GDP) in Kenya in 1991 to that in 1992?
Give a very brief answer. 0.99. What is the ratio of the Value added (% of GDP) of Moldova in 1991 to that in 1992?
Provide a succinct answer. 1.36. What is the ratio of the Value added (% of GDP) of Bahrain in 1991 to that in 1993?
Provide a succinct answer. 0.97. What is the ratio of the Value added (% of GDP) in Central African Republic in 1991 to that in 1993?
Offer a very short reply. 1.03. What is the ratio of the Value added (% of GDP) of Kenya in 1991 to that in 1993?
Ensure brevity in your answer.  1.01. What is the ratio of the Value added (% of GDP) of Moldova in 1991 to that in 1993?
Offer a very short reply. 1.02. What is the ratio of the Value added (% of GDP) of Bahrain in 1991 to that in 1994?
Offer a terse response. 0.96. What is the ratio of the Value added (% of GDP) of Kenya in 1991 to that in 1994?
Your response must be concise. 1.06. What is the ratio of the Value added (% of GDP) of Moldova in 1991 to that in 1994?
Your answer should be compact. 0.74. What is the ratio of the Value added (% of GDP) of Central African Republic in 1991 to that in 1995?
Your response must be concise. 1.02. What is the ratio of the Value added (% of GDP) in Kenya in 1991 to that in 1995?
Keep it short and to the point. 0.99. What is the ratio of the Value added (% of GDP) in Moldova in 1991 to that in 1995?
Give a very brief answer. 0.69. What is the ratio of the Value added (% of GDP) in Central African Republic in 1992 to that in 1993?
Ensure brevity in your answer.  1.01. What is the ratio of the Value added (% of GDP) in Kenya in 1992 to that in 1993?
Keep it short and to the point. 1.03. What is the ratio of the Value added (% of GDP) in Moldova in 1992 to that in 1993?
Keep it short and to the point. 0.75. What is the ratio of the Value added (% of GDP) in Central African Republic in 1992 to that in 1994?
Make the answer very short. 0.97. What is the ratio of the Value added (% of GDP) in Kenya in 1992 to that in 1994?
Keep it short and to the point. 1.07. What is the ratio of the Value added (% of GDP) in Moldova in 1992 to that in 1994?
Your response must be concise. 0.54. What is the ratio of the Value added (% of GDP) of Bahrain in 1992 to that in 1995?
Ensure brevity in your answer.  1.05. What is the ratio of the Value added (% of GDP) in Kenya in 1992 to that in 1995?
Give a very brief answer. 1. What is the ratio of the Value added (% of GDP) in Moldova in 1992 to that in 1995?
Provide a short and direct response. 0.5. What is the ratio of the Value added (% of GDP) of Bahrain in 1993 to that in 1994?
Provide a short and direct response. 0.99. What is the ratio of the Value added (% of GDP) in Central African Republic in 1993 to that in 1994?
Give a very brief answer. 0.96. What is the ratio of the Value added (% of GDP) of Kenya in 1993 to that in 1994?
Provide a succinct answer. 1.04. What is the ratio of the Value added (% of GDP) of Moldova in 1993 to that in 1994?
Offer a terse response. 0.72. What is the ratio of the Value added (% of GDP) of Bahrain in 1993 to that in 1995?
Provide a succinct answer. 1.03. What is the ratio of the Value added (% of GDP) in Central African Republic in 1993 to that in 1995?
Offer a terse response. 0.98. What is the ratio of the Value added (% of GDP) of Moldova in 1993 to that in 1995?
Offer a very short reply. 0.67. What is the ratio of the Value added (% of GDP) in Bahrain in 1994 to that in 1995?
Give a very brief answer. 1.04. What is the ratio of the Value added (% of GDP) in Central African Republic in 1994 to that in 1995?
Ensure brevity in your answer.  1.02. What is the ratio of the Value added (% of GDP) in Kenya in 1994 to that in 1995?
Offer a very short reply. 0.94. What is the ratio of the Value added (% of GDP) in Moldova in 1994 to that in 1995?
Keep it short and to the point. 0.93. What is the difference between the highest and the second highest Value added (% of GDP) in Bahrain?
Offer a terse response. 0.16. What is the difference between the highest and the second highest Value added (% of GDP) in Central African Republic?
Make the answer very short. 0.02. What is the difference between the highest and the second highest Value added (% of GDP) in Kenya?
Keep it short and to the point. 0.03. What is the difference between the highest and the second highest Value added (% of GDP) of Moldova?
Ensure brevity in your answer.  2.42. What is the difference between the highest and the lowest Value added (% of GDP) in Bahrain?
Ensure brevity in your answer.  8.56. What is the difference between the highest and the lowest Value added (% of GDP) of Central African Republic?
Your response must be concise. 2.54. What is the difference between the highest and the lowest Value added (% of GDP) of Kenya?
Offer a terse response. 3.45. What is the difference between the highest and the lowest Value added (% of GDP) in Moldova?
Make the answer very short. 17.25. 